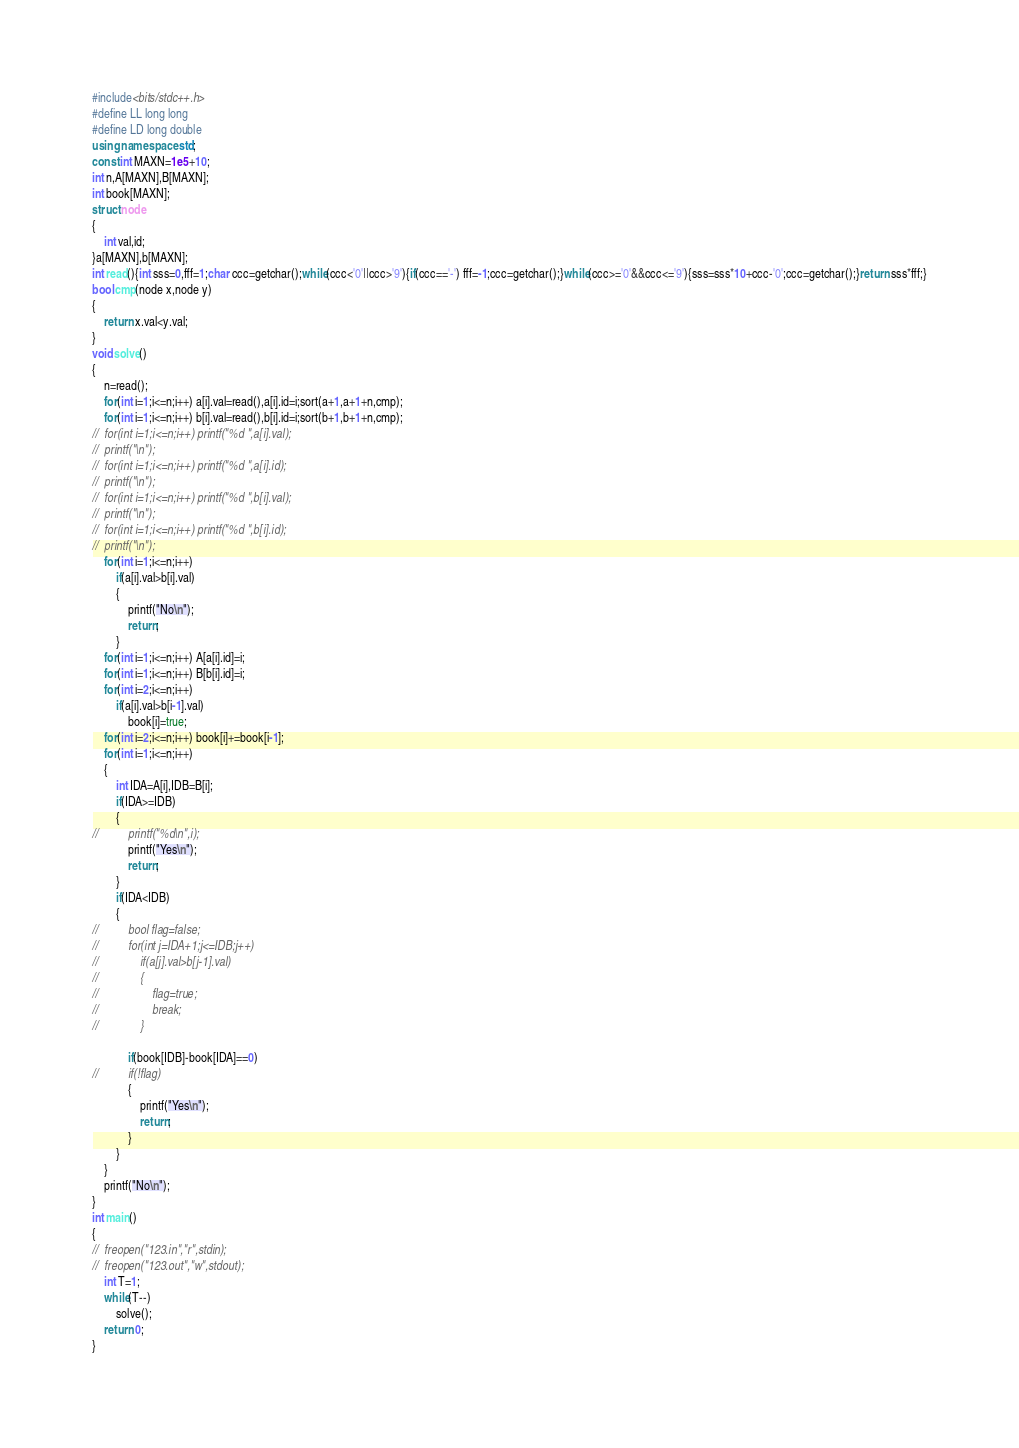Convert code to text. <code><loc_0><loc_0><loc_500><loc_500><_C++_>#include<bits/stdc++.h>
#define LL long long
#define LD long double
using namespace std;
const int MAXN=1e5+10;
int n,A[MAXN],B[MAXN];
int book[MAXN];
struct node
{
	int val,id;
}a[MAXN],b[MAXN];
int read(){int sss=0,fff=1;char ccc=getchar();while(ccc<'0'||ccc>'9'){if(ccc=='-') fff=-1;ccc=getchar();}while(ccc>='0'&&ccc<='9'){sss=sss*10+ccc-'0';ccc=getchar();}return sss*fff;}
bool cmp(node x,node y)
{
	return x.val<y.val;
}
void solve()
{
	n=read();
	for(int i=1;i<=n;i++) a[i].val=read(),a[i].id=i;sort(a+1,a+1+n,cmp);
	for(int i=1;i<=n;i++) b[i].val=read(),b[i].id=i;sort(b+1,b+1+n,cmp);
//	for(int i=1;i<=n;i++) printf("%d ",a[i].val);
//	printf("\n");
//	for(int i=1;i<=n;i++) printf("%d ",a[i].id);
//	printf("\n");
//	for(int i=1;i<=n;i++) printf("%d ",b[i].val);
//	printf("\n");
//	for(int i=1;i<=n;i++) printf("%d ",b[i].id);
//	printf("\n");
	for(int i=1;i<=n;i++)
		if(a[i].val>b[i].val)
		{
			printf("No\n");
			return;
		}
	for(int i=1;i<=n;i++) A[a[i].id]=i;
	for(int i=1;i<=n;i++) B[b[i].id]=i;
	for(int i=2;i<=n;i++)
		if(a[i].val>b[i-1].val)
			book[i]=true;
	for(int i=2;i<=n;i++) book[i]+=book[i-1];
	for(int i=1;i<=n;i++)
	{
		int IDA=A[i],IDB=B[i];
		if(IDA>=IDB)
		{
//			printf("%d\n",i);
			printf("Yes\n");
			return;
		}
		if(IDA<IDB)
		{
//			bool flag=false;
//			for(int j=IDA+1;j<=IDB;j++)
//				if(a[j].val>b[j-1].val)
//				{
//					flag=true;
//					break;
//				}
			
			if(book[IDB]-book[IDA]==0)
//			if(!flag)
			{
				printf("Yes\n");
				return;
			}
		}
	}
	printf("No\n");
}
int main()
{
//	freopen("123.in","r",stdin);
//	freopen("123.out","w",stdout);
	int T=1;
	while(T--)
		solve();
	return 0;
}</code> 